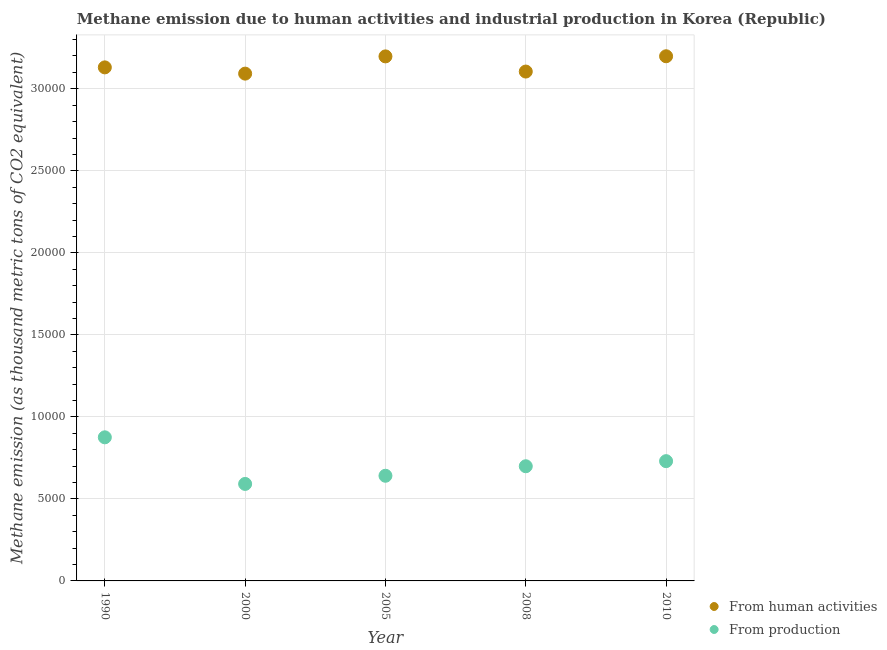How many different coloured dotlines are there?
Offer a very short reply. 2. What is the amount of emissions generated from industries in 2008?
Provide a short and direct response. 6990.7. Across all years, what is the maximum amount of emissions generated from industries?
Give a very brief answer. 8754.2. Across all years, what is the minimum amount of emissions generated from industries?
Your response must be concise. 5912.8. In which year was the amount of emissions from human activities maximum?
Keep it short and to the point. 2010. What is the total amount of emissions generated from industries in the graph?
Offer a terse response. 3.54e+04. What is the difference between the amount of emissions from human activities in 2000 and that in 2010?
Provide a succinct answer. -1058.8. What is the difference between the amount of emissions from human activities in 2005 and the amount of emissions generated from industries in 2008?
Provide a succinct answer. 2.50e+04. What is the average amount of emissions generated from industries per year?
Provide a short and direct response. 7073.86. In the year 2008, what is the difference between the amount of emissions from human activities and amount of emissions generated from industries?
Provide a short and direct response. 2.41e+04. What is the ratio of the amount of emissions from human activities in 1990 to that in 2010?
Your answer should be compact. 0.98. Is the amount of emissions from human activities in 2000 less than that in 2010?
Your answer should be very brief. Yes. What is the difference between the highest and the second highest amount of emissions from human activities?
Your response must be concise. 7.9. What is the difference between the highest and the lowest amount of emissions from human activities?
Your answer should be very brief. 1058.8. In how many years, is the amount of emissions from human activities greater than the average amount of emissions from human activities taken over all years?
Provide a short and direct response. 2. Does the amount of emissions from human activities monotonically increase over the years?
Provide a succinct answer. No. Is the amount of emissions from human activities strictly greater than the amount of emissions generated from industries over the years?
Provide a succinct answer. Yes. How many dotlines are there?
Your response must be concise. 2. How many years are there in the graph?
Your response must be concise. 5. What is the difference between two consecutive major ticks on the Y-axis?
Ensure brevity in your answer.  5000. Are the values on the major ticks of Y-axis written in scientific E-notation?
Give a very brief answer. No. Where does the legend appear in the graph?
Give a very brief answer. Bottom right. How are the legend labels stacked?
Your answer should be compact. Vertical. What is the title of the graph?
Your answer should be compact. Methane emission due to human activities and industrial production in Korea (Republic). What is the label or title of the Y-axis?
Offer a very short reply. Methane emission (as thousand metric tons of CO2 equivalent). What is the Methane emission (as thousand metric tons of CO2 equivalent) in From human activities in 1990?
Ensure brevity in your answer.  3.13e+04. What is the Methane emission (as thousand metric tons of CO2 equivalent) in From production in 1990?
Provide a succinct answer. 8754.2. What is the Methane emission (as thousand metric tons of CO2 equivalent) of From human activities in 2000?
Your response must be concise. 3.09e+04. What is the Methane emission (as thousand metric tons of CO2 equivalent) in From production in 2000?
Provide a succinct answer. 5912.8. What is the Methane emission (as thousand metric tons of CO2 equivalent) of From human activities in 2005?
Give a very brief answer. 3.20e+04. What is the Methane emission (as thousand metric tons of CO2 equivalent) of From production in 2005?
Your answer should be very brief. 6410.4. What is the Methane emission (as thousand metric tons of CO2 equivalent) in From human activities in 2008?
Offer a terse response. 3.11e+04. What is the Methane emission (as thousand metric tons of CO2 equivalent) of From production in 2008?
Ensure brevity in your answer.  6990.7. What is the Methane emission (as thousand metric tons of CO2 equivalent) of From human activities in 2010?
Your answer should be very brief. 3.20e+04. What is the Methane emission (as thousand metric tons of CO2 equivalent) of From production in 2010?
Provide a succinct answer. 7301.2. Across all years, what is the maximum Methane emission (as thousand metric tons of CO2 equivalent) of From human activities?
Your answer should be very brief. 3.20e+04. Across all years, what is the maximum Methane emission (as thousand metric tons of CO2 equivalent) of From production?
Offer a terse response. 8754.2. Across all years, what is the minimum Methane emission (as thousand metric tons of CO2 equivalent) in From human activities?
Provide a short and direct response. 3.09e+04. Across all years, what is the minimum Methane emission (as thousand metric tons of CO2 equivalent) of From production?
Keep it short and to the point. 5912.8. What is the total Methane emission (as thousand metric tons of CO2 equivalent) of From human activities in the graph?
Provide a succinct answer. 1.57e+05. What is the total Methane emission (as thousand metric tons of CO2 equivalent) in From production in the graph?
Make the answer very short. 3.54e+04. What is the difference between the Methane emission (as thousand metric tons of CO2 equivalent) of From human activities in 1990 and that in 2000?
Keep it short and to the point. 381.1. What is the difference between the Methane emission (as thousand metric tons of CO2 equivalent) in From production in 1990 and that in 2000?
Provide a succinct answer. 2841.4. What is the difference between the Methane emission (as thousand metric tons of CO2 equivalent) of From human activities in 1990 and that in 2005?
Your answer should be compact. -669.8. What is the difference between the Methane emission (as thousand metric tons of CO2 equivalent) of From production in 1990 and that in 2005?
Offer a very short reply. 2343.8. What is the difference between the Methane emission (as thousand metric tons of CO2 equivalent) in From human activities in 1990 and that in 2008?
Your answer should be very brief. 254.6. What is the difference between the Methane emission (as thousand metric tons of CO2 equivalent) of From production in 1990 and that in 2008?
Keep it short and to the point. 1763.5. What is the difference between the Methane emission (as thousand metric tons of CO2 equivalent) in From human activities in 1990 and that in 2010?
Your response must be concise. -677.7. What is the difference between the Methane emission (as thousand metric tons of CO2 equivalent) in From production in 1990 and that in 2010?
Your answer should be compact. 1453. What is the difference between the Methane emission (as thousand metric tons of CO2 equivalent) in From human activities in 2000 and that in 2005?
Your answer should be compact. -1050.9. What is the difference between the Methane emission (as thousand metric tons of CO2 equivalent) of From production in 2000 and that in 2005?
Make the answer very short. -497.6. What is the difference between the Methane emission (as thousand metric tons of CO2 equivalent) in From human activities in 2000 and that in 2008?
Provide a succinct answer. -126.5. What is the difference between the Methane emission (as thousand metric tons of CO2 equivalent) of From production in 2000 and that in 2008?
Provide a short and direct response. -1077.9. What is the difference between the Methane emission (as thousand metric tons of CO2 equivalent) of From human activities in 2000 and that in 2010?
Your answer should be compact. -1058.8. What is the difference between the Methane emission (as thousand metric tons of CO2 equivalent) of From production in 2000 and that in 2010?
Provide a succinct answer. -1388.4. What is the difference between the Methane emission (as thousand metric tons of CO2 equivalent) of From human activities in 2005 and that in 2008?
Your response must be concise. 924.4. What is the difference between the Methane emission (as thousand metric tons of CO2 equivalent) of From production in 2005 and that in 2008?
Offer a very short reply. -580.3. What is the difference between the Methane emission (as thousand metric tons of CO2 equivalent) of From production in 2005 and that in 2010?
Make the answer very short. -890.8. What is the difference between the Methane emission (as thousand metric tons of CO2 equivalent) of From human activities in 2008 and that in 2010?
Provide a short and direct response. -932.3. What is the difference between the Methane emission (as thousand metric tons of CO2 equivalent) of From production in 2008 and that in 2010?
Your answer should be very brief. -310.5. What is the difference between the Methane emission (as thousand metric tons of CO2 equivalent) in From human activities in 1990 and the Methane emission (as thousand metric tons of CO2 equivalent) in From production in 2000?
Provide a succinct answer. 2.54e+04. What is the difference between the Methane emission (as thousand metric tons of CO2 equivalent) in From human activities in 1990 and the Methane emission (as thousand metric tons of CO2 equivalent) in From production in 2005?
Keep it short and to the point. 2.49e+04. What is the difference between the Methane emission (as thousand metric tons of CO2 equivalent) in From human activities in 1990 and the Methane emission (as thousand metric tons of CO2 equivalent) in From production in 2008?
Give a very brief answer. 2.43e+04. What is the difference between the Methane emission (as thousand metric tons of CO2 equivalent) of From human activities in 1990 and the Methane emission (as thousand metric tons of CO2 equivalent) of From production in 2010?
Your answer should be very brief. 2.40e+04. What is the difference between the Methane emission (as thousand metric tons of CO2 equivalent) in From human activities in 2000 and the Methane emission (as thousand metric tons of CO2 equivalent) in From production in 2005?
Ensure brevity in your answer.  2.45e+04. What is the difference between the Methane emission (as thousand metric tons of CO2 equivalent) in From human activities in 2000 and the Methane emission (as thousand metric tons of CO2 equivalent) in From production in 2008?
Ensure brevity in your answer.  2.39e+04. What is the difference between the Methane emission (as thousand metric tons of CO2 equivalent) in From human activities in 2000 and the Methane emission (as thousand metric tons of CO2 equivalent) in From production in 2010?
Your answer should be compact. 2.36e+04. What is the difference between the Methane emission (as thousand metric tons of CO2 equivalent) in From human activities in 2005 and the Methane emission (as thousand metric tons of CO2 equivalent) in From production in 2008?
Give a very brief answer. 2.50e+04. What is the difference between the Methane emission (as thousand metric tons of CO2 equivalent) of From human activities in 2005 and the Methane emission (as thousand metric tons of CO2 equivalent) of From production in 2010?
Keep it short and to the point. 2.47e+04. What is the difference between the Methane emission (as thousand metric tons of CO2 equivalent) of From human activities in 2008 and the Methane emission (as thousand metric tons of CO2 equivalent) of From production in 2010?
Give a very brief answer. 2.38e+04. What is the average Methane emission (as thousand metric tons of CO2 equivalent) in From human activities per year?
Give a very brief answer. 3.14e+04. What is the average Methane emission (as thousand metric tons of CO2 equivalent) in From production per year?
Provide a short and direct response. 7073.86. In the year 1990, what is the difference between the Methane emission (as thousand metric tons of CO2 equivalent) of From human activities and Methane emission (as thousand metric tons of CO2 equivalent) of From production?
Provide a short and direct response. 2.26e+04. In the year 2000, what is the difference between the Methane emission (as thousand metric tons of CO2 equivalent) of From human activities and Methane emission (as thousand metric tons of CO2 equivalent) of From production?
Offer a terse response. 2.50e+04. In the year 2005, what is the difference between the Methane emission (as thousand metric tons of CO2 equivalent) in From human activities and Methane emission (as thousand metric tons of CO2 equivalent) in From production?
Make the answer very short. 2.56e+04. In the year 2008, what is the difference between the Methane emission (as thousand metric tons of CO2 equivalent) of From human activities and Methane emission (as thousand metric tons of CO2 equivalent) of From production?
Ensure brevity in your answer.  2.41e+04. In the year 2010, what is the difference between the Methane emission (as thousand metric tons of CO2 equivalent) in From human activities and Methane emission (as thousand metric tons of CO2 equivalent) in From production?
Your response must be concise. 2.47e+04. What is the ratio of the Methane emission (as thousand metric tons of CO2 equivalent) of From human activities in 1990 to that in 2000?
Your answer should be very brief. 1.01. What is the ratio of the Methane emission (as thousand metric tons of CO2 equivalent) in From production in 1990 to that in 2000?
Your response must be concise. 1.48. What is the ratio of the Methane emission (as thousand metric tons of CO2 equivalent) of From human activities in 1990 to that in 2005?
Make the answer very short. 0.98. What is the ratio of the Methane emission (as thousand metric tons of CO2 equivalent) of From production in 1990 to that in 2005?
Offer a very short reply. 1.37. What is the ratio of the Methane emission (as thousand metric tons of CO2 equivalent) in From human activities in 1990 to that in 2008?
Make the answer very short. 1.01. What is the ratio of the Methane emission (as thousand metric tons of CO2 equivalent) of From production in 1990 to that in 2008?
Provide a short and direct response. 1.25. What is the ratio of the Methane emission (as thousand metric tons of CO2 equivalent) in From human activities in 1990 to that in 2010?
Offer a terse response. 0.98. What is the ratio of the Methane emission (as thousand metric tons of CO2 equivalent) in From production in 1990 to that in 2010?
Your answer should be compact. 1.2. What is the ratio of the Methane emission (as thousand metric tons of CO2 equivalent) of From human activities in 2000 to that in 2005?
Ensure brevity in your answer.  0.97. What is the ratio of the Methane emission (as thousand metric tons of CO2 equivalent) of From production in 2000 to that in 2005?
Ensure brevity in your answer.  0.92. What is the ratio of the Methane emission (as thousand metric tons of CO2 equivalent) of From human activities in 2000 to that in 2008?
Your response must be concise. 1. What is the ratio of the Methane emission (as thousand metric tons of CO2 equivalent) in From production in 2000 to that in 2008?
Offer a terse response. 0.85. What is the ratio of the Methane emission (as thousand metric tons of CO2 equivalent) in From human activities in 2000 to that in 2010?
Ensure brevity in your answer.  0.97. What is the ratio of the Methane emission (as thousand metric tons of CO2 equivalent) in From production in 2000 to that in 2010?
Ensure brevity in your answer.  0.81. What is the ratio of the Methane emission (as thousand metric tons of CO2 equivalent) in From human activities in 2005 to that in 2008?
Keep it short and to the point. 1.03. What is the ratio of the Methane emission (as thousand metric tons of CO2 equivalent) in From production in 2005 to that in 2008?
Offer a terse response. 0.92. What is the ratio of the Methane emission (as thousand metric tons of CO2 equivalent) of From production in 2005 to that in 2010?
Offer a terse response. 0.88. What is the ratio of the Methane emission (as thousand metric tons of CO2 equivalent) of From human activities in 2008 to that in 2010?
Give a very brief answer. 0.97. What is the ratio of the Methane emission (as thousand metric tons of CO2 equivalent) in From production in 2008 to that in 2010?
Offer a very short reply. 0.96. What is the difference between the highest and the second highest Methane emission (as thousand metric tons of CO2 equivalent) in From human activities?
Your answer should be very brief. 7.9. What is the difference between the highest and the second highest Methane emission (as thousand metric tons of CO2 equivalent) of From production?
Your answer should be compact. 1453. What is the difference between the highest and the lowest Methane emission (as thousand metric tons of CO2 equivalent) in From human activities?
Offer a very short reply. 1058.8. What is the difference between the highest and the lowest Methane emission (as thousand metric tons of CO2 equivalent) in From production?
Provide a succinct answer. 2841.4. 